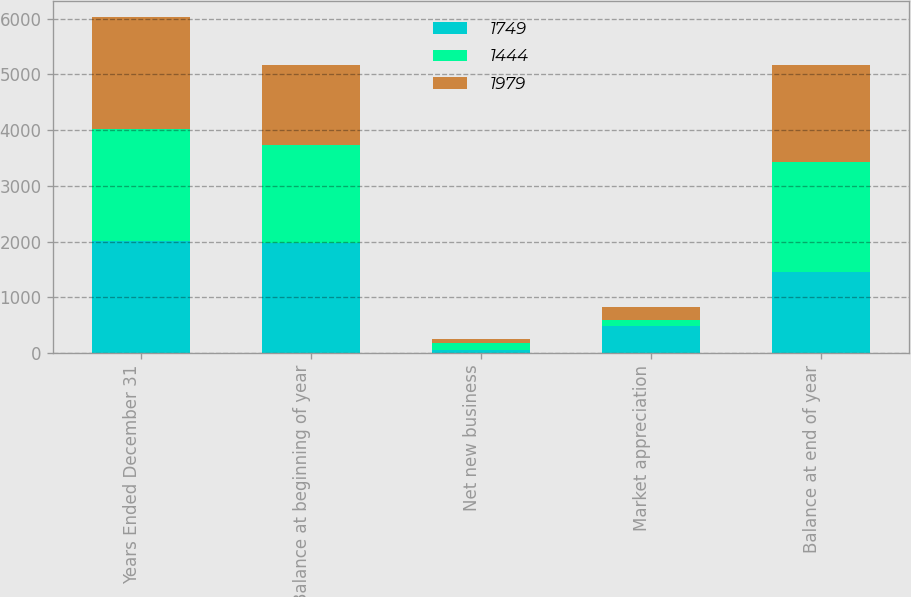Convert chart. <chart><loc_0><loc_0><loc_500><loc_500><stacked_bar_chart><ecel><fcel>Years Ended December 31<fcel>Balance at beginning of year<fcel>Net new business<fcel>Market appreciation<fcel>Balance at end of year<nl><fcel>1749<fcel>2008<fcel>1979<fcel>55<fcel>480<fcel>1444<nl><fcel>1444<fcel>2007<fcel>1749<fcel>116<fcel>114<fcel>1979<nl><fcel>1979<fcel>2006<fcel>1441<fcel>86<fcel>222<fcel>1749<nl></chart> 